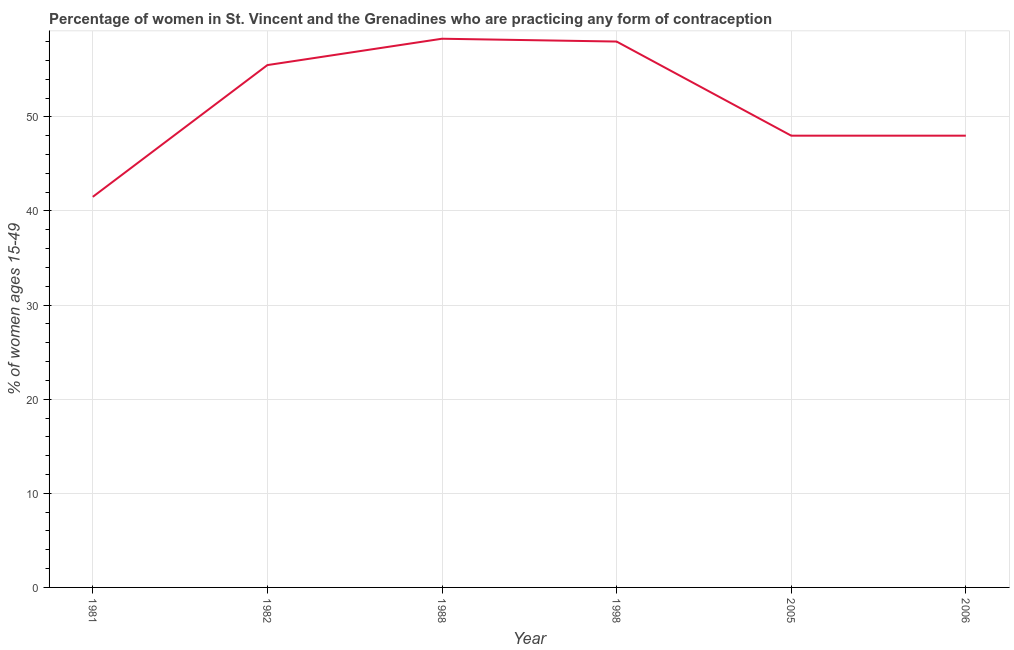What is the contraceptive prevalence in 1988?
Provide a succinct answer. 58.3. Across all years, what is the maximum contraceptive prevalence?
Offer a terse response. 58.3. Across all years, what is the minimum contraceptive prevalence?
Make the answer very short. 41.5. In which year was the contraceptive prevalence minimum?
Ensure brevity in your answer.  1981. What is the sum of the contraceptive prevalence?
Offer a very short reply. 309.3. What is the difference between the contraceptive prevalence in 1982 and 1988?
Offer a very short reply. -2.8. What is the average contraceptive prevalence per year?
Offer a very short reply. 51.55. What is the median contraceptive prevalence?
Give a very brief answer. 51.75. Do a majority of the years between 2006 and 1981 (inclusive) have contraceptive prevalence greater than 20 %?
Make the answer very short. Yes. What is the ratio of the contraceptive prevalence in 1988 to that in 1998?
Provide a succinct answer. 1.01. What is the difference between the highest and the second highest contraceptive prevalence?
Your response must be concise. 0.3. What is the difference between the highest and the lowest contraceptive prevalence?
Offer a terse response. 16.8. In how many years, is the contraceptive prevalence greater than the average contraceptive prevalence taken over all years?
Make the answer very short. 3. Does the contraceptive prevalence monotonically increase over the years?
Offer a very short reply. No. How many lines are there?
Offer a terse response. 1. Are the values on the major ticks of Y-axis written in scientific E-notation?
Provide a succinct answer. No. Does the graph contain grids?
Make the answer very short. Yes. What is the title of the graph?
Offer a very short reply. Percentage of women in St. Vincent and the Grenadines who are practicing any form of contraception. What is the label or title of the X-axis?
Provide a succinct answer. Year. What is the label or title of the Y-axis?
Your answer should be very brief. % of women ages 15-49. What is the % of women ages 15-49 of 1981?
Offer a very short reply. 41.5. What is the % of women ages 15-49 in 1982?
Your answer should be very brief. 55.5. What is the % of women ages 15-49 of 1988?
Your response must be concise. 58.3. What is the % of women ages 15-49 in 2005?
Provide a succinct answer. 48. What is the % of women ages 15-49 of 2006?
Provide a succinct answer. 48. What is the difference between the % of women ages 15-49 in 1981 and 1988?
Offer a terse response. -16.8. What is the difference between the % of women ages 15-49 in 1981 and 1998?
Your answer should be very brief. -16.5. What is the difference between the % of women ages 15-49 in 1981 and 2005?
Give a very brief answer. -6.5. What is the difference between the % of women ages 15-49 in 1981 and 2006?
Offer a terse response. -6.5. What is the difference between the % of women ages 15-49 in 1988 and 1998?
Give a very brief answer. 0.3. What is the difference between the % of women ages 15-49 in 1988 and 2006?
Ensure brevity in your answer.  10.3. What is the difference between the % of women ages 15-49 in 1998 and 2005?
Your answer should be very brief. 10. What is the difference between the % of women ages 15-49 in 1998 and 2006?
Your answer should be compact. 10. What is the ratio of the % of women ages 15-49 in 1981 to that in 1982?
Offer a very short reply. 0.75. What is the ratio of the % of women ages 15-49 in 1981 to that in 1988?
Provide a succinct answer. 0.71. What is the ratio of the % of women ages 15-49 in 1981 to that in 1998?
Offer a very short reply. 0.72. What is the ratio of the % of women ages 15-49 in 1981 to that in 2005?
Keep it short and to the point. 0.86. What is the ratio of the % of women ages 15-49 in 1981 to that in 2006?
Provide a short and direct response. 0.86. What is the ratio of the % of women ages 15-49 in 1982 to that in 2005?
Give a very brief answer. 1.16. What is the ratio of the % of women ages 15-49 in 1982 to that in 2006?
Your response must be concise. 1.16. What is the ratio of the % of women ages 15-49 in 1988 to that in 1998?
Keep it short and to the point. 1. What is the ratio of the % of women ages 15-49 in 1988 to that in 2005?
Provide a succinct answer. 1.22. What is the ratio of the % of women ages 15-49 in 1988 to that in 2006?
Keep it short and to the point. 1.22. What is the ratio of the % of women ages 15-49 in 1998 to that in 2005?
Your response must be concise. 1.21. What is the ratio of the % of women ages 15-49 in 1998 to that in 2006?
Your answer should be very brief. 1.21. 